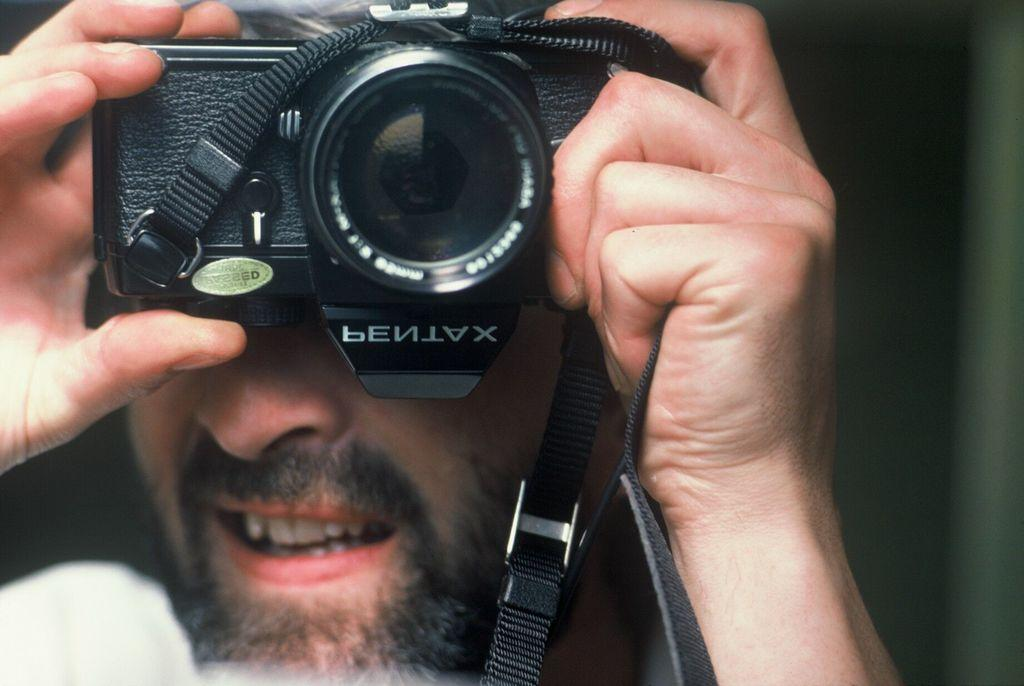What is the main subject of the image? The main subject of the image is a man. What is the man holding in his hands? The man is holding a camera in his hands. Can you describe any additional details about the camera? Yes, there is text written on the camera. How many cows can be seen grazing in the background of the image? There are no cows present in the image; it features a man holding a camera. What type of clock is hanging on the wall behind the man in the image? There is no clock visible in the image; it only shows a man holding a camera with text written on it. 